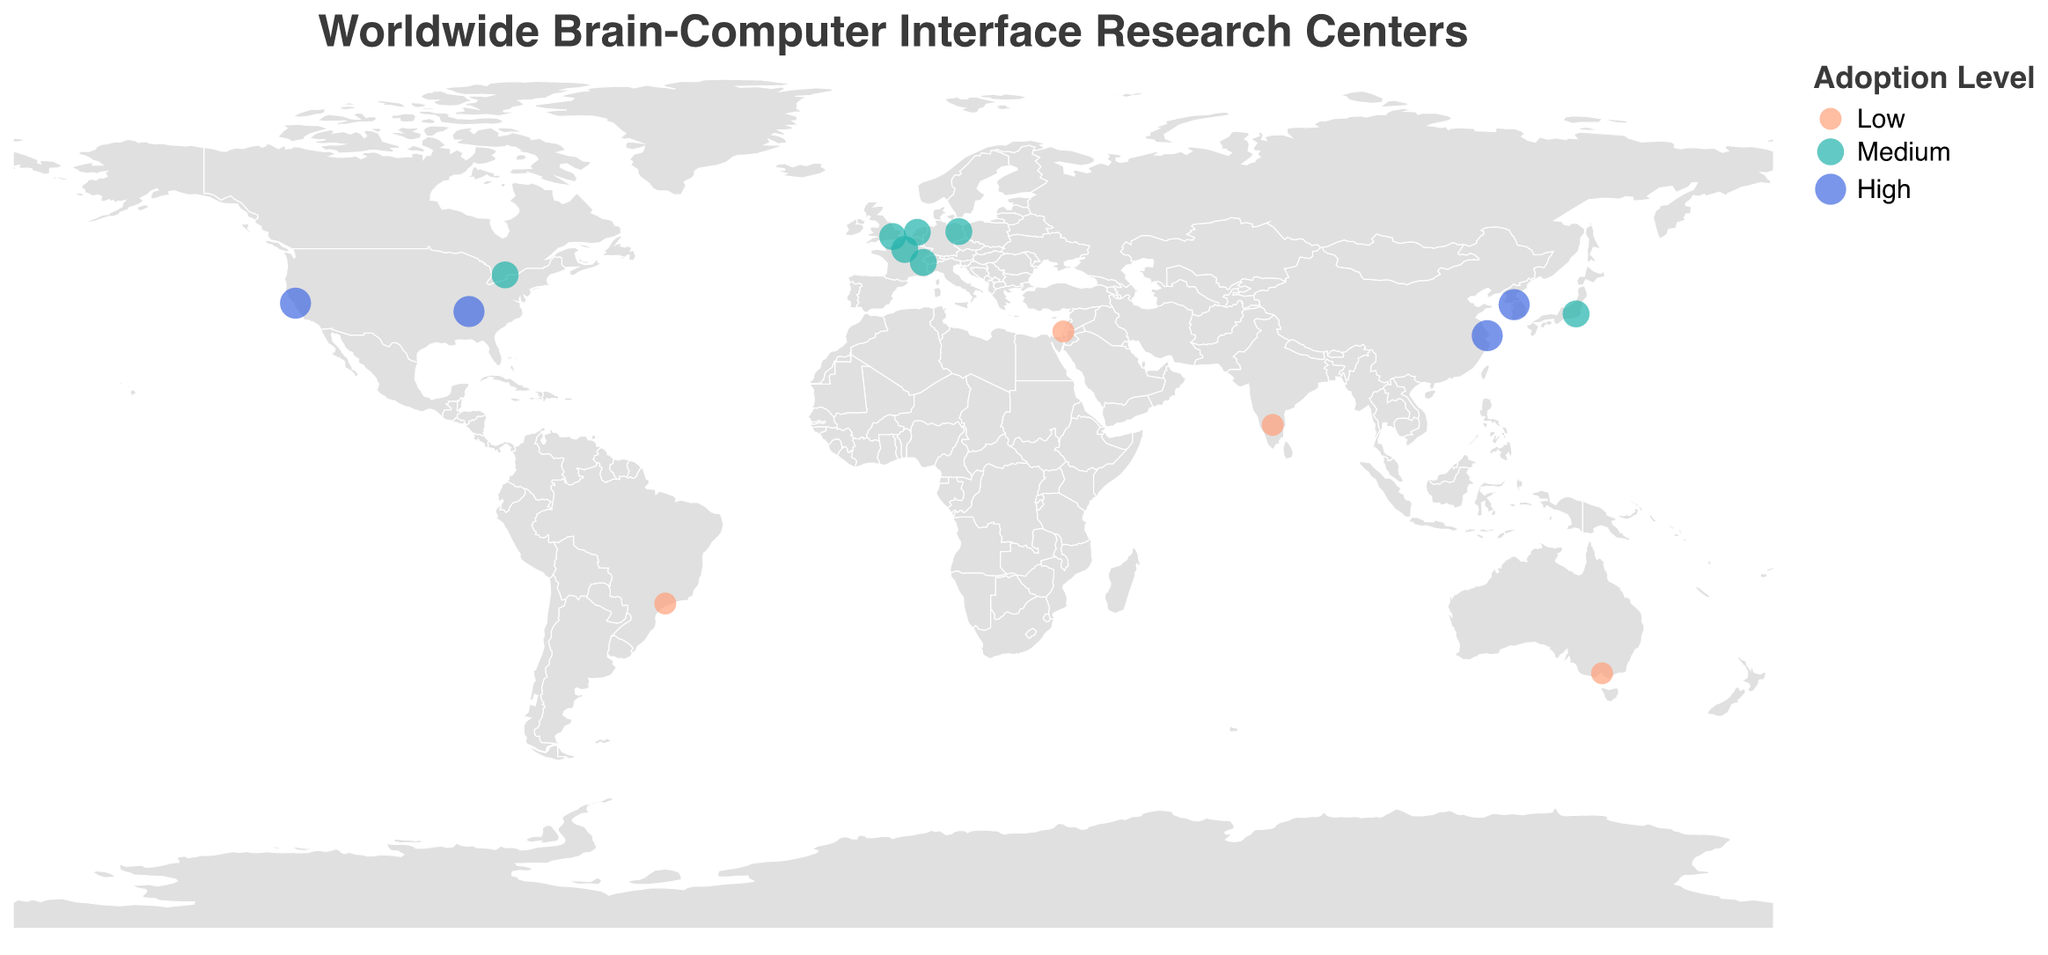What is the title of the figure? The title of the figure is usually displayed at the top and helps in understanding the main topic of the visualization.
Answer: Worldwide Brain-Computer Interface Research Centers How many research centers are located in the USA? To answer this, count the data points shown within the USA boundary in the figure.
Answer: 2 Which country has research centers with the highest adoption level for Brain-Computer Interface technology? Look for the data points with the largest circles and 'High' adoption level, then identify the countries they correspond to.
Answer: USA, China, South Korea Which city in Japan is represented in the figure? Locate the data point in Japan and refer to the tooltip or label for the city information.
Answer: Tokyo Compare the adoption levels of BCIs between Toronto (Canada) and São Paulo (Brazil). Which city has a higher level of adoption? Compare the size or color of the circles representing Toronto and São Paulo; the larger circle or darker color indicates a higher adoption level.
Answer: Toronto What is the primary research focus of Vanderbilt University in Nashville? Refer to the tooltip information for Vanderbilt University located in Nashville.
Answer: Multisensory Integration List all the European cities included in the figure. Identify the data points in the European region and list their associated cities.
Answer: Berlin, London, Paris, Amsterdam, Geneva What type of Brain-Computer Interfaces is the focus of the research center in Shanghai? Refer to the tooltip information for the data point located in Shanghai.
Answer: P300-based BCI Determine the average adoption level for the research centers in the figure. Assign numerical values to adoption levels ('Low' = 1, 'Medium' = 2, 'High' = 3), sum them, and then divide by the number of centers.
Answer: (3+3+2+3+2+2+1+2+2+3+1+2+1+2+1)/15 = 30/15 = 2 (Medium) Which cities have a similar adoption level of 'Low' for BCI technologies? Locate the data points with the smallest circles and 'Low' level adoption, then check the tooltips for city names.
Answer: Melbourne, São Paulo, Bengaluru, Tel Aviv 